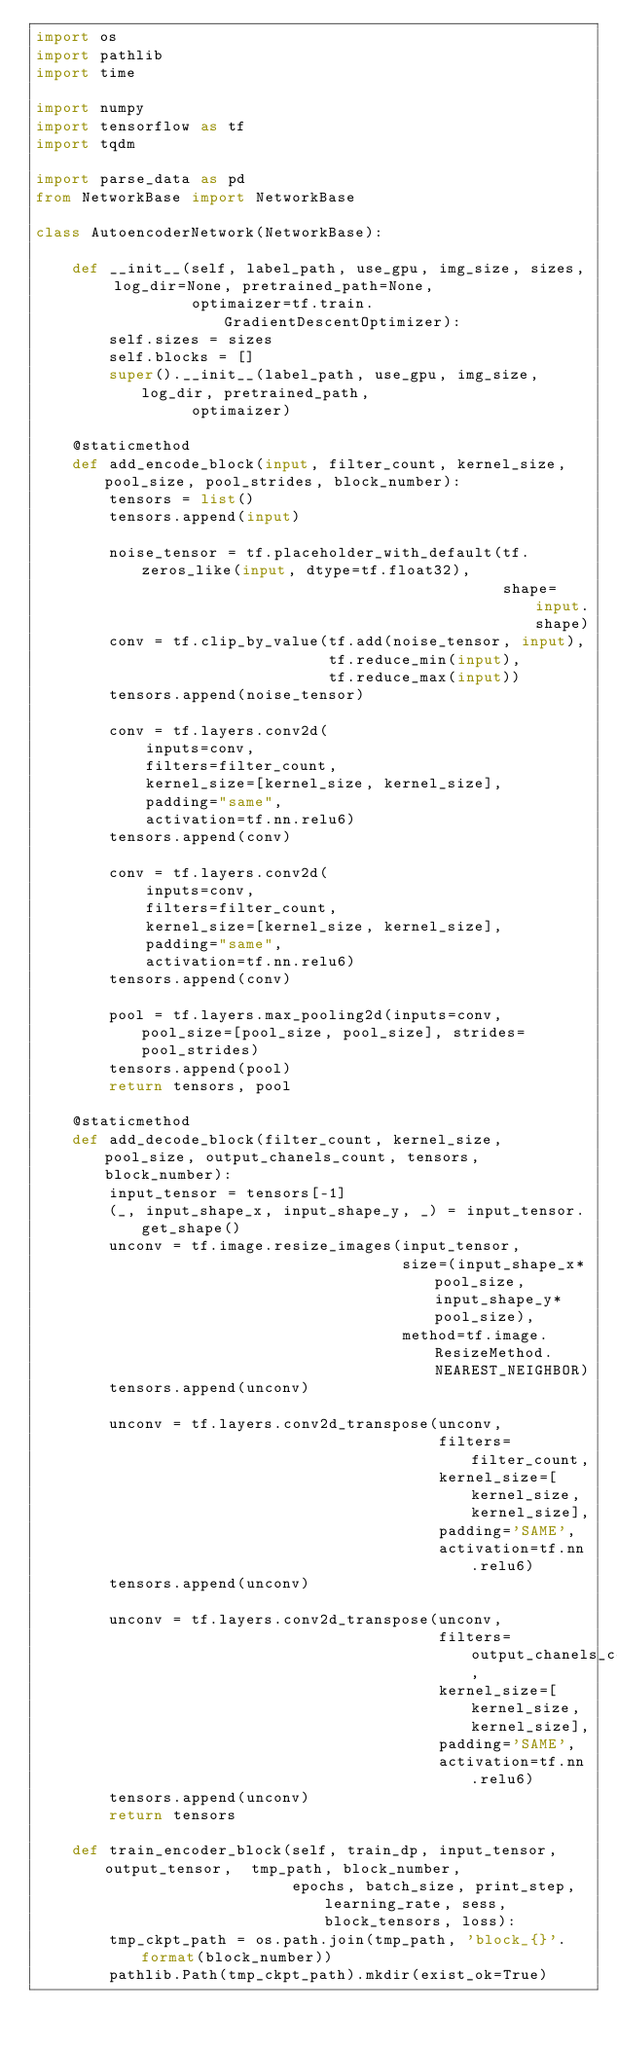<code> <loc_0><loc_0><loc_500><loc_500><_Python_>import os
import pathlib
import time

import numpy
import tensorflow as tf
import tqdm

import parse_data as pd
from NetworkBase import NetworkBase

class AutoencoderNetwork(NetworkBase):

    def __init__(self, label_path, use_gpu, img_size, sizes, log_dir=None, pretrained_path=None,
                 optimaizer=tf.train.GradientDescentOptimizer):
        self.sizes = sizes
        self.blocks = []
        super().__init__(label_path, use_gpu, img_size, log_dir, pretrained_path,
                 optimaizer)

    @staticmethod
    def add_encode_block(input, filter_count, kernel_size, pool_size, pool_strides, block_number):
        tensors = list()
        tensors.append(input)

        noise_tensor = tf.placeholder_with_default(tf.zeros_like(input, dtype=tf.float32),
                                                   shape=input.shape)
        conv = tf.clip_by_value(tf.add(noise_tensor, input),
                                tf.reduce_min(input),
                                tf.reduce_max(input))
        tensors.append(noise_tensor)

        conv = tf.layers.conv2d(
            inputs=conv,
            filters=filter_count,
            kernel_size=[kernel_size, kernel_size],
            padding="same",
            activation=tf.nn.relu6)
        tensors.append(conv)

        conv = tf.layers.conv2d(
            inputs=conv,
            filters=filter_count,
            kernel_size=[kernel_size, kernel_size],
            padding="same",
            activation=tf.nn.relu6)
        tensors.append(conv)

        pool = tf.layers.max_pooling2d(inputs=conv, pool_size=[pool_size, pool_size], strides=pool_strides)
        tensors.append(pool)
        return tensors, pool

    @staticmethod
    def add_decode_block(filter_count, kernel_size, pool_size, output_chanels_count, tensors, block_number):
        input_tensor = tensors[-1]
        (_, input_shape_x, input_shape_y, _) = input_tensor.get_shape()
        unconv = tf.image.resize_images(input_tensor,
                                        size=(input_shape_x*pool_size, input_shape_y*pool_size),
                                        method=tf.image.ResizeMethod.NEAREST_NEIGHBOR)
        tensors.append(unconv)

        unconv = tf.layers.conv2d_transpose(unconv,
                                            filters=filter_count,
                                            kernel_size=[kernel_size, kernel_size],
                                            padding='SAME',
                                            activation=tf.nn.relu6)
        tensors.append(unconv)

        unconv = tf.layers.conv2d_transpose(unconv,
                                            filters=output_chanels_count,
                                            kernel_size=[kernel_size, kernel_size],
                                            padding='SAME',
                                            activation=tf.nn.relu6)
        tensors.append(unconv)
        return tensors

    def train_encoder_block(self, train_dp, input_tensor, output_tensor,  tmp_path, block_number,
                            epochs, batch_size, print_step, learning_rate, sess, block_tensors, loss):
        tmp_ckpt_path = os.path.join(tmp_path, 'block_{}'.format(block_number))
        pathlib.Path(tmp_ckpt_path).mkdir(exist_ok=True)</code> 